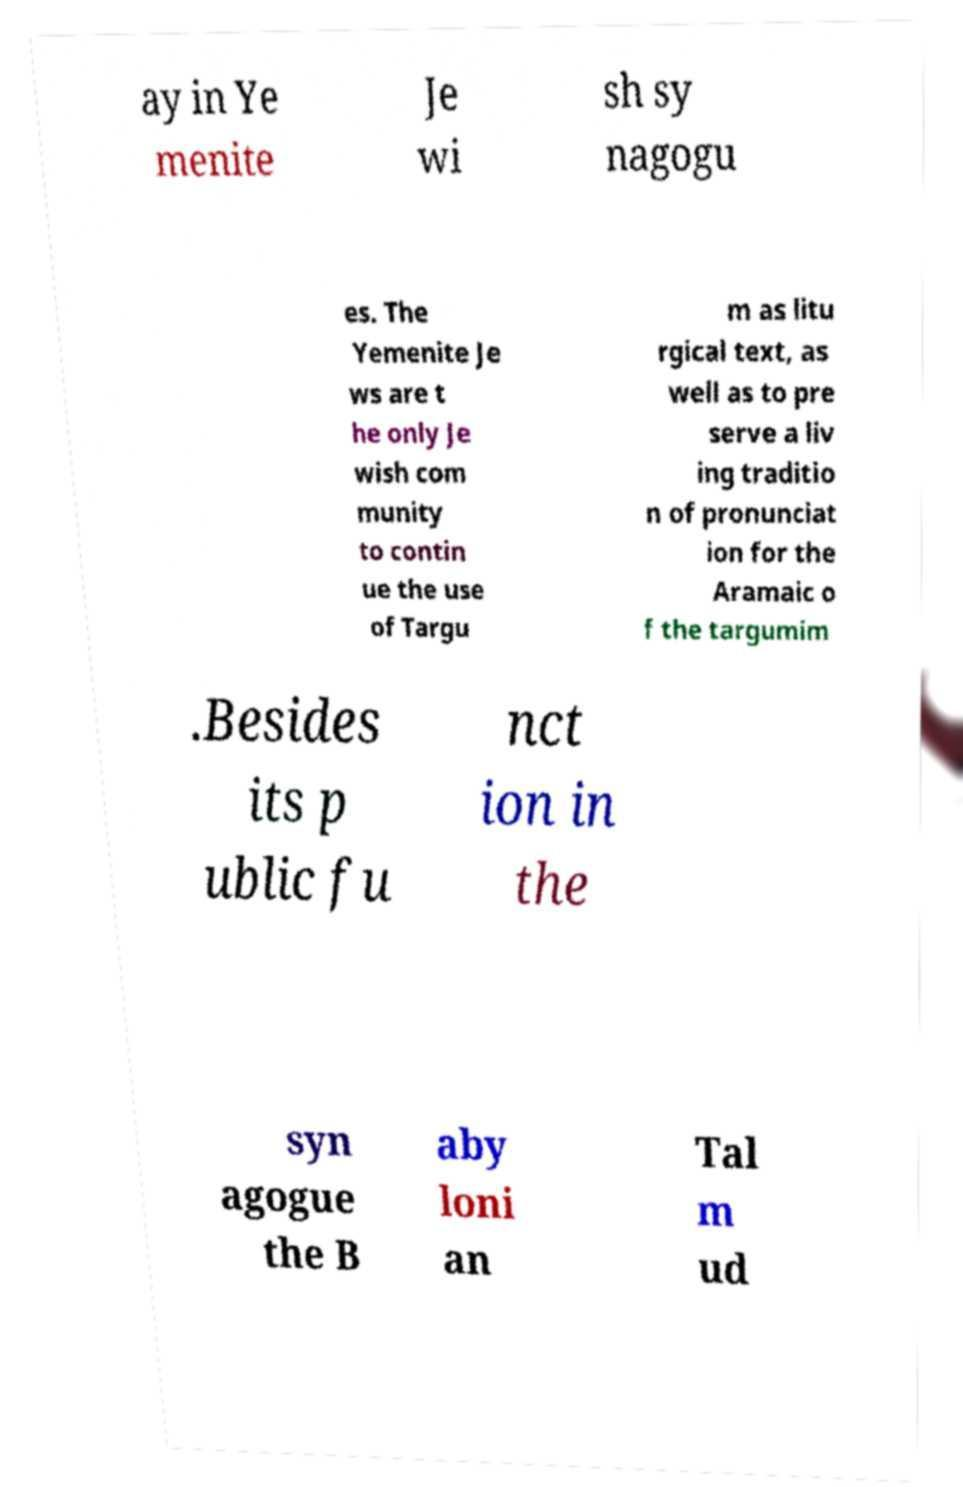I need the written content from this picture converted into text. Can you do that? ay in Ye menite Je wi sh sy nagogu es. The Yemenite Je ws are t he only Je wish com munity to contin ue the use of Targu m as litu rgical text, as well as to pre serve a liv ing traditio n of pronunciat ion for the Aramaic o f the targumim .Besides its p ublic fu nct ion in the syn agogue the B aby loni an Tal m ud 